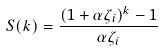Convert formula to latex. <formula><loc_0><loc_0><loc_500><loc_500>S ( k ) = \frac { ( 1 + \alpha \zeta _ { i } ) ^ { k } - 1 } { \alpha \zeta _ { i } }</formula> 